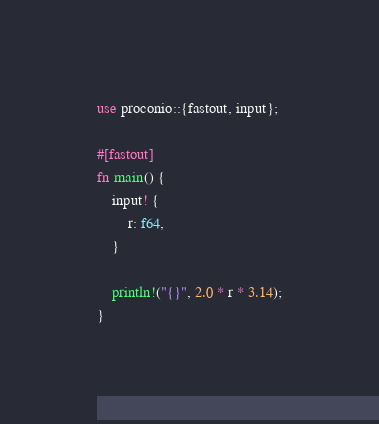<code> <loc_0><loc_0><loc_500><loc_500><_Rust_>use proconio::{fastout, input};

#[fastout]
fn main() {
    input! {
        r: f64,
    }

    println!("{}", 2.0 * r * 3.14);
}
</code> 